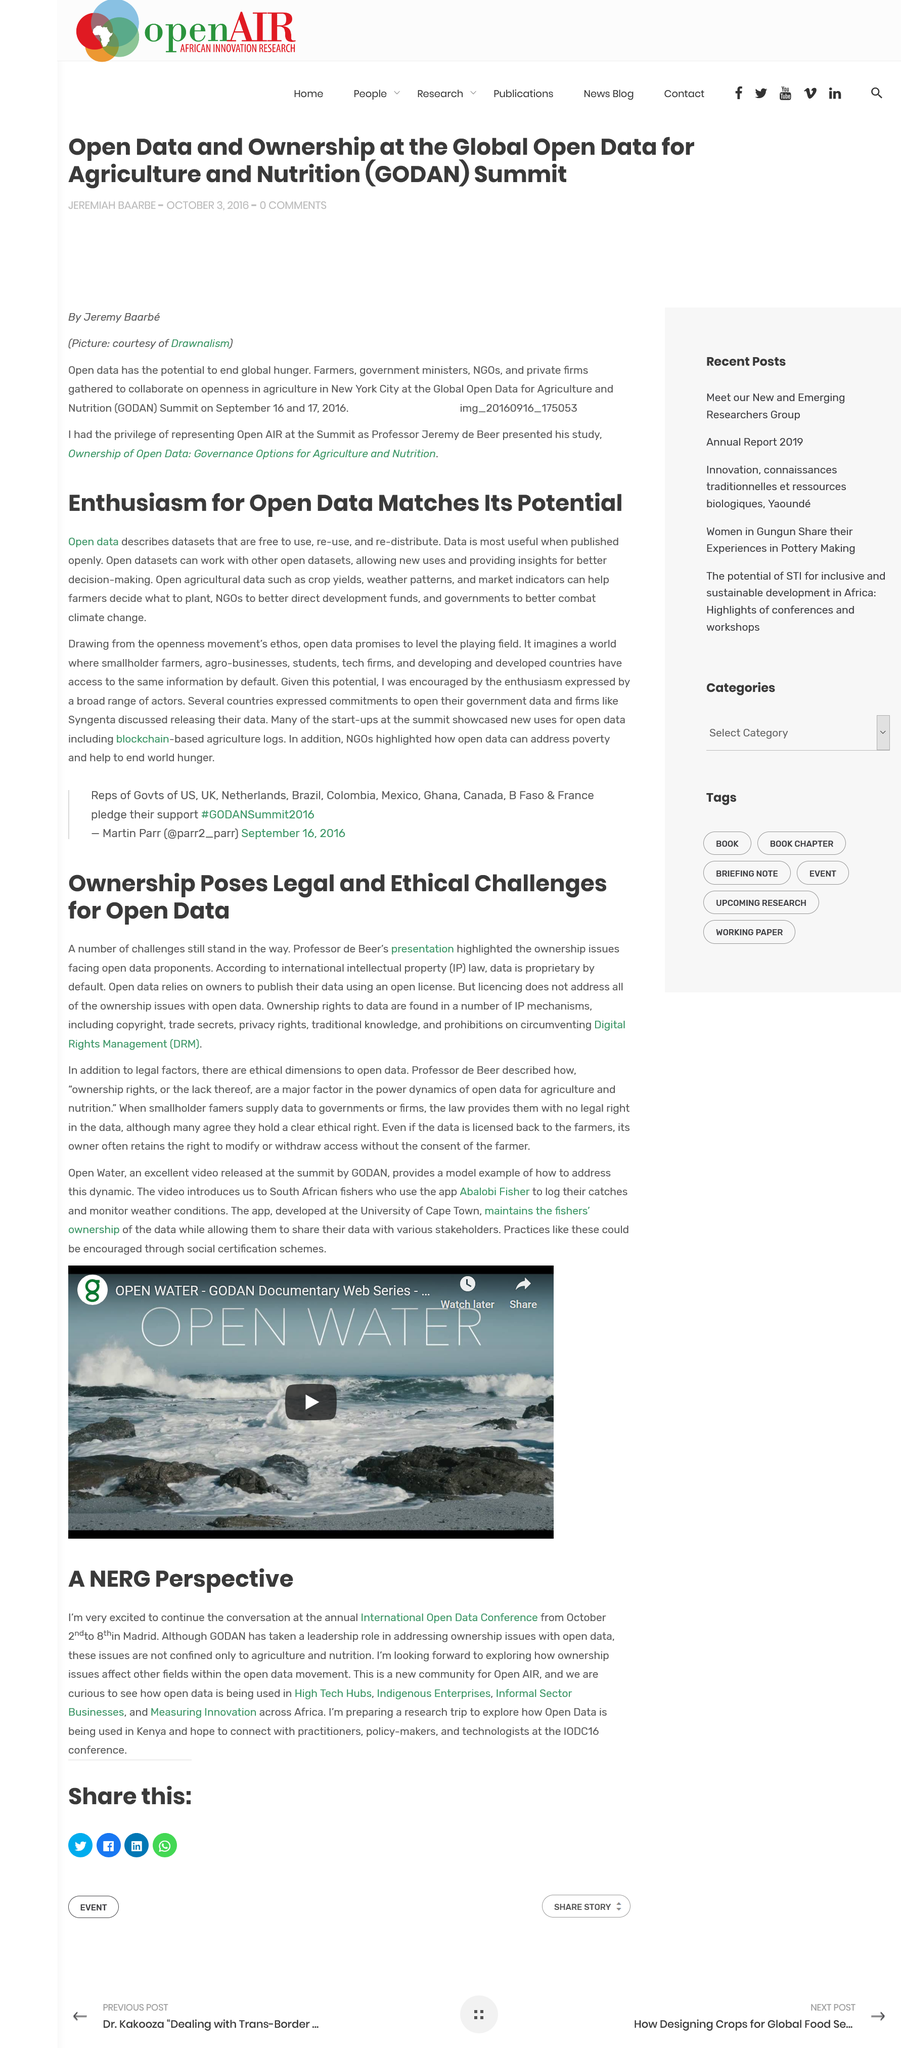Outline some significant characteristics in this image. The International Open Data Conference is an annual event that will take place from October 2nd to 8th. The research trip will take place in Kenya. The International Open Data Conference is held in Madrid. Open agricultural data can facilitate decision-making for farmers in selecting crops, enhance the efficiency of NGOs in allocating development resources, and enable governments to effectively address climate change by providing valuable insights into weather patterns, soil quality, and other relevant factors. We believe in leveling the playing field by defaulting to openness, providing equal access to information for all to ensure a fair and just society. 